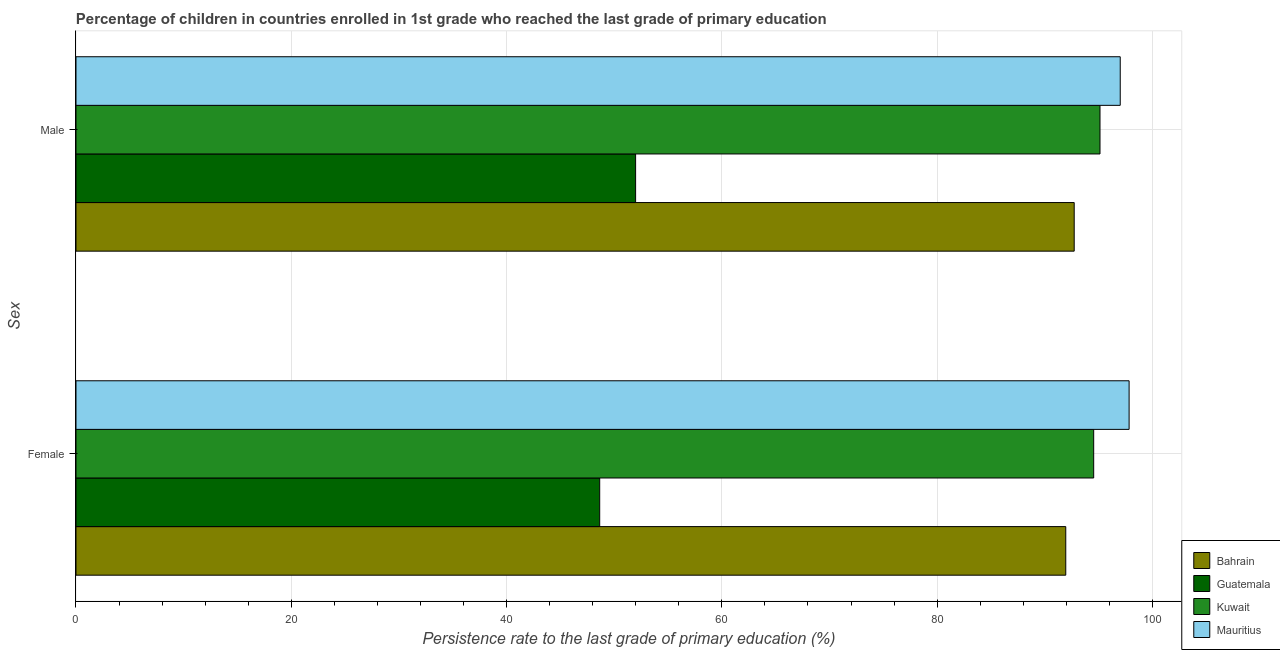How many groups of bars are there?
Offer a very short reply. 2. How many bars are there on the 1st tick from the top?
Offer a very short reply. 4. What is the persistence rate of female students in Bahrain?
Your answer should be compact. 91.95. Across all countries, what is the maximum persistence rate of male students?
Make the answer very short. 97.01. Across all countries, what is the minimum persistence rate of female students?
Offer a very short reply. 48.65. In which country was the persistence rate of male students maximum?
Offer a terse response. Mauritius. In which country was the persistence rate of male students minimum?
Your answer should be compact. Guatemala. What is the total persistence rate of female students in the graph?
Your answer should be very brief. 332.98. What is the difference between the persistence rate of female students in Bahrain and that in Mauritius?
Offer a terse response. -5.88. What is the difference between the persistence rate of female students in Mauritius and the persistence rate of male students in Guatemala?
Provide a short and direct response. 45.84. What is the average persistence rate of female students per country?
Keep it short and to the point. 83.24. What is the difference between the persistence rate of female students and persistence rate of male students in Kuwait?
Your answer should be very brief. -0.59. What is the ratio of the persistence rate of male students in Kuwait to that in Bahrain?
Ensure brevity in your answer.  1.03. Is the persistence rate of male students in Bahrain less than that in Mauritius?
Make the answer very short. Yes. What does the 1st bar from the top in Female represents?
Ensure brevity in your answer.  Mauritius. What does the 4th bar from the bottom in Female represents?
Offer a terse response. Mauritius. How many bars are there?
Provide a succinct answer. 8. What is the difference between two consecutive major ticks on the X-axis?
Give a very brief answer. 20. Does the graph contain grids?
Your answer should be compact. Yes. How many legend labels are there?
Offer a terse response. 4. What is the title of the graph?
Offer a very short reply. Percentage of children in countries enrolled in 1st grade who reached the last grade of primary education. What is the label or title of the X-axis?
Keep it short and to the point. Persistence rate to the last grade of primary education (%). What is the label or title of the Y-axis?
Ensure brevity in your answer.  Sex. What is the Persistence rate to the last grade of primary education (%) in Bahrain in Female?
Your answer should be very brief. 91.95. What is the Persistence rate to the last grade of primary education (%) in Guatemala in Female?
Give a very brief answer. 48.65. What is the Persistence rate to the last grade of primary education (%) of Kuwait in Female?
Your response must be concise. 94.54. What is the Persistence rate to the last grade of primary education (%) in Mauritius in Female?
Offer a very short reply. 97.83. What is the Persistence rate to the last grade of primary education (%) in Bahrain in Male?
Make the answer very short. 92.73. What is the Persistence rate to the last grade of primary education (%) in Guatemala in Male?
Make the answer very short. 51.99. What is the Persistence rate to the last grade of primary education (%) of Kuwait in Male?
Offer a very short reply. 95.13. What is the Persistence rate to the last grade of primary education (%) of Mauritius in Male?
Provide a succinct answer. 97.01. Across all Sex, what is the maximum Persistence rate to the last grade of primary education (%) of Bahrain?
Give a very brief answer. 92.73. Across all Sex, what is the maximum Persistence rate to the last grade of primary education (%) of Guatemala?
Provide a succinct answer. 51.99. Across all Sex, what is the maximum Persistence rate to the last grade of primary education (%) in Kuwait?
Your answer should be very brief. 95.13. Across all Sex, what is the maximum Persistence rate to the last grade of primary education (%) of Mauritius?
Make the answer very short. 97.83. Across all Sex, what is the minimum Persistence rate to the last grade of primary education (%) of Bahrain?
Make the answer very short. 91.95. Across all Sex, what is the minimum Persistence rate to the last grade of primary education (%) in Guatemala?
Provide a succinct answer. 48.65. Across all Sex, what is the minimum Persistence rate to the last grade of primary education (%) of Kuwait?
Your response must be concise. 94.54. Across all Sex, what is the minimum Persistence rate to the last grade of primary education (%) of Mauritius?
Your answer should be very brief. 97.01. What is the total Persistence rate to the last grade of primary education (%) in Bahrain in the graph?
Offer a very short reply. 184.68. What is the total Persistence rate to the last grade of primary education (%) in Guatemala in the graph?
Keep it short and to the point. 100.64. What is the total Persistence rate to the last grade of primary education (%) of Kuwait in the graph?
Your response must be concise. 189.67. What is the total Persistence rate to the last grade of primary education (%) of Mauritius in the graph?
Keep it short and to the point. 194.84. What is the difference between the Persistence rate to the last grade of primary education (%) of Bahrain in Female and that in Male?
Your response must be concise. -0.78. What is the difference between the Persistence rate to the last grade of primary education (%) in Guatemala in Female and that in Male?
Make the answer very short. -3.34. What is the difference between the Persistence rate to the last grade of primary education (%) in Kuwait in Female and that in Male?
Ensure brevity in your answer.  -0.59. What is the difference between the Persistence rate to the last grade of primary education (%) of Mauritius in Female and that in Male?
Provide a succinct answer. 0.82. What is the difference between the Persistence rate to the last grade of primary education (%) in Bahrain in Female and the Persistence rate to the last grade of primary education (%) in Guatemala in Male?
Provide a short and direct response. 39.96. What is the difference between the Persistence rate to the last grade of primary education (%) in Bahrain in Female and the Persistence rate to the last grade of primary education (%) in Kuwait in Male?
Keep it short and to the point. -3.18. What is the difference between the Persistence rate to the last grade of primary education (%) in Bahrain in Female and the Persistence rate to the last grade of primary education (%) in Mauritius in Male?
Offer a very short reply. -5.06. What is the difference between the Persistence rate to the last grade of primary education (%) in Guatemala in Female and the Persistence rate to the last grade of primary education (%) in Kuwait in Male?
Ensure brevity in your answer.  -46.48. What is the difference between the Persistence rate to the last grade of primary education (%) of Guatemala in Female and the Persistence rate to the last grade of primary education (%) of Mauritius in Male?
Provide a short and direct response. -48.36. What is the difference between the Persistence rate to the last grade of primary education (%) in Kuwait in Female and the Persistence rate to the last grade of primary education (%) in Mauritius in Male?
Your response must be concise. -2.47. What is the average Persistence rate to the last grade of primary education (%) in Bahrain per Sex?
Offer a terse response. 92.34. What is the average Persistence rate to the last grade of primary education (%) of Guatemala per Sex?
Your response must be concise. 50.32. What is the average Persistence rate to the last grade of primary education (%) of Kuwait per Sex?
Your answer should be very brief. 94.84. What is the average Persistence rate to the last grade of primary education (%) of Mauritius per Sex?
Your answer should be very brief. 97.42. What is the difference between the Persistence rate to the last grade of primary education (%) in Bahrain and Persistence rate to the last grade of primary education (%) in Guatemala in Female?
Give a very brief answer. 43.3. What is the difference between the Persistence rate to the last grade of primary education (%) in Bahrain and Persistence rate to the last grade of primary education (%) in Kuwait in Female?
Your response must be concise. -2.59. What is the difference between the Persistence rate to the last grade of primary education (%) of Bahrain and Persistence rate to the last grade of primary education (%) of Mauritius in Female?
Offer a very short reply. -5.88. What is the difference between the Persistence rate to the last grade of primary education (%) of Guatemala and Persistence rate to the last grade of primary education (%) of Kuwait in Female?
Provide a short and direct response. -45.89. What is the difference between the Persistence rate to the last grade of primary education (%) of Guatemala and Persistence rate to the last grade of primary education (%) of Mauritius in Female?
Offer a very short reply. -49.18. What is the difference between the Persistence rate to the last grade of primary education (%) of Kuwait and Persistence rate to the last grade of primary education (%) of Mauritius in Female?
Keep it short and to the point. -3.29. What is the difference between the Persistence rate to the last grade of primary education (%) of Bahrain and Persistence rate to the last grade of primary education (%) of Guatemala in Male?
Offer a very short reply. 40.74. What is the difference between the Persistence rate to the last grade of primary education (%) of Bahrain and Persistence rate to the last grade of primary education (%) of Kuwait in Male?
Ensure brevity in your answer.  -2.4. What is the difference between the Persistence rate to the last grade of primary education (%) of Bahrain and Persistence rate to the last grade of primary education (%) of Mauritius in Male?
Make the answer very short. -4.28. What is the difference between the Persistence rate to the last grade of primary education (%) of Guatemala and Persistence rate to the last grade of primary education (%) of Kuwait in Male?
Offer a very short reply. -43.14. What is the difference between the Persistence rate to the last grade of primary education (%) of Guatemala and Persistence rate to the last grade of primary education (%) of Mauritius in Male?
Provide a short and direct response. -45.02. What is the difference between the Persistence rate to the last grade of primary education (%) in Kuwait and Persistence rate to the last grade of primary education (%) in Mauritius in Male?
Your answer should be compact. -1.88. What is the ratio of the Persistence rate to the last grade of primary education (%) in Guatemala in Female to that in Male?
Provide a short and direct response. 0.94. What is the ratio of the Persistence rate to the last grade of primary education (%) in Mauritius in Female to that in Male?
Ensure brevity in your answer.  1.01. What is the difference between the highest and the second highest Persistence rate to the last grade of primary education (%) in Bahrain?
Provide a short and direct response. 0.78. What is the difference between the highest and the second highest Persistence rate to the last grade of primary education (%) in Guatemala?
Make the answer very short. 3.34. What is the difference between the highest and the second highest Persistence rate to the last grade of primary education (%) of Kuwait?
Your response must be concise. 0.59. What is the difference between the highest and the second highest Persistence rate to the last grade of primary education (%) in Mauritius?
Ensure brevity in your answer.  0.82. What is the difference between the highest and the lowest Persistence rate to the last grade of primary education (%) in Bahrain?
Make the answer very short. 0.78. What is the difference between the highest and the lowest Persistence rate to the last grade of primary education (%) in Guatemala?
Your answer should be compact. 3.34. What is the difference between the highest and the lowest Persistence rate to the last grade of primary education (%) of Kuwait?
Offer a terse response. 0.59. What is the difference between the highest and the lowest Persistence rate to the last grade of primary education (%) of Mauritius?
Make the answer very short. 0.82. 